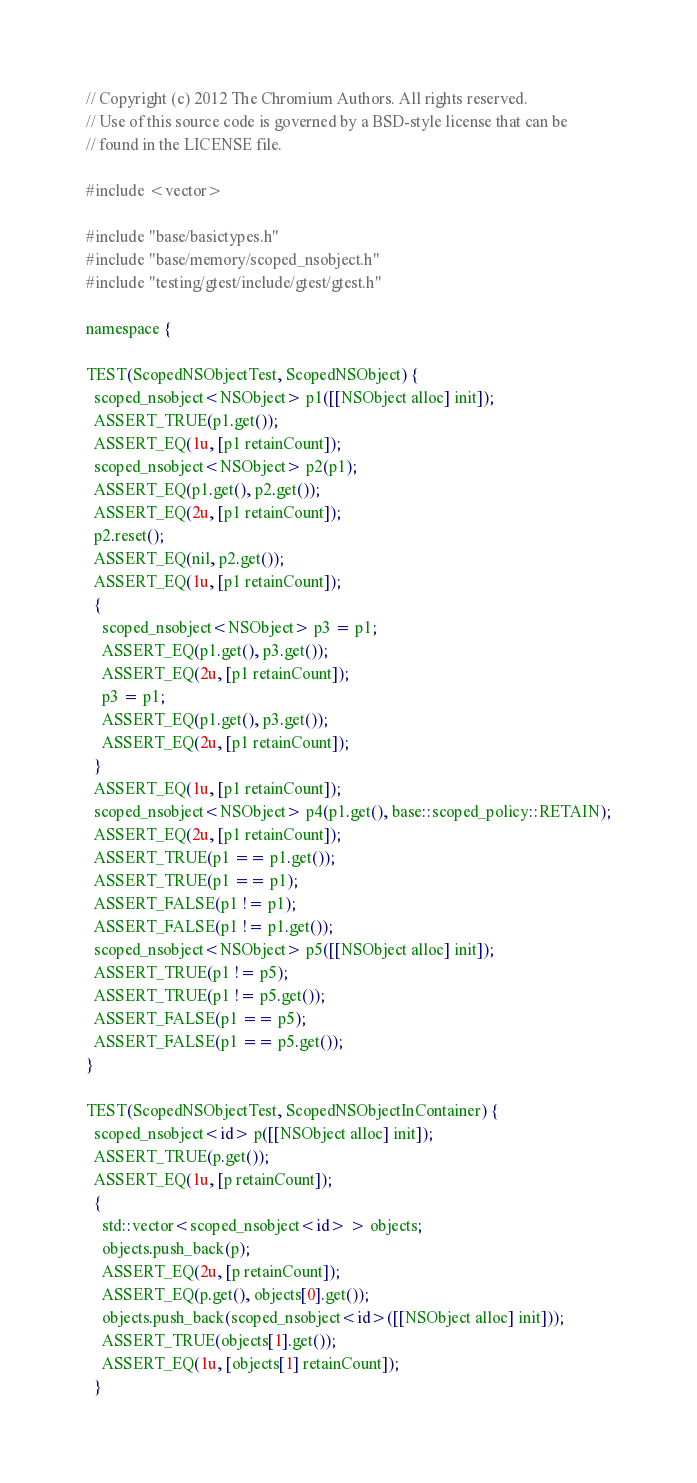Convert code to text. <code><loc_0><loc_0><loc_500><loc_500><_ObjectiveC_>// Copyright (c) 2012 The Chromium Authors. All rights reserved.
// Use of this source code is governed by a BSD-style license that can be
// found in the LICENSE file.

#include <vector>

#include "base/basictypes.h"
#include "base/memory/scoped_nsobject.h"
#include "testing/gtest/include/gtest/gtest.h"

namespace {

TEST(ScopedNSObjectTest, ScopedNSObject) {
  scoped_nsobject<NSObject> p1([[NSObject alloc] init]);
  ASSERT_TRUE(p1.get());
  ASSERT_EQ(1u, [p1 retainCount]);
  scoped_nsobject<NSObject> p2(p1);
  ASSERT_EQ(p1.get(), p2.get());
  ASSERT_EQ(2u, [p1 retainCount]);
  p2.reset();
  ASSERT_EQ(nil, p2.get());
  ASSERT_EQ(1u, [p1 retainCount]);
  {
    scoped_nsobject<NSObject> p3 = p1;
    ASSERT_EQ(p1.get(), p3.get());
    ASSERT_EQ(2u, [p1 retainCount]);
    p3 = p1;
    ASSERT_EQ(p1.get(), p3.get());
    ASSERT_EQ(2u, [p1 retainCount]);
  }
  ASSERT_EQ(1u, [p1 retainCount]);
  scoped_nsobject<NSObject> p4(p1.get(), base::scoped_policy::RETAIN);
  ASSERT_EQ(2u, [p1 retainCount]);
  ASSERT_TRUE(p1 == p1.get());
  ASSERT_TRUE(p1 == p1);
  ASSERT_FALSE(p1 != p1);
  ASSERT_FALSE(p1 != p1.get());
  scoped_nsobject<NSObject> p5([[NSObject alloc] init]);
  ASSERT_TRUE(p1 != p5);
  ASSERT_TRUE(p1 != p5.get());
  ASSERT_FALSE(p1 == p5);
  ASSERT_FALSE(p1 == p5.get());
}

TEST(ScopedNSObjectTest, ScopedNSObjectInContainer) {
  scoped_nsobject<id> p([[NSObject alloc] init]);
  ASSERT_TRUE(p.get());
  ASSERT_EQ(1u, [p retainCount]);
  {
    std::vector<scoped_nsobject<id> > objects;
    objects.push_back(p);
    ASSERT_EQ(2u, [p retainCount]);
    ASSERT_EQ(p.get(), objects[0].get());
    objects.push_back(scoped_nsobject<id>([[NSObject alloc] init]));
    ASSERT_TRUE(objects[1].get());
    ASSERT_EQ(1u, [objects[1] retainCount]);
  }</code> 